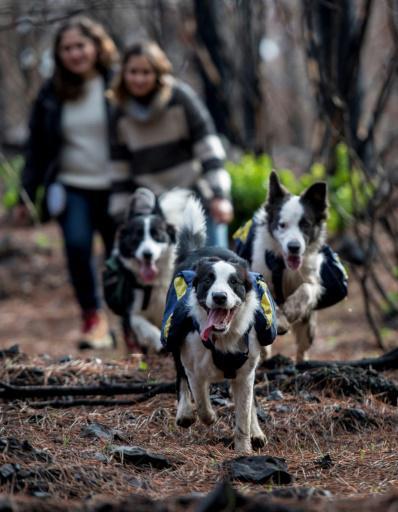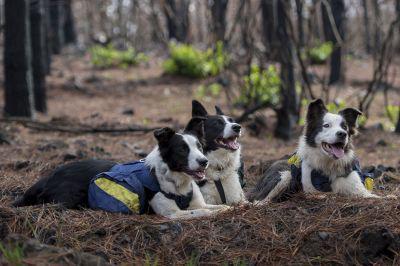The first image is the image on the left, the second image is the image on the right. Examine the images to the left and right. Is the description "The left image contains two dogs that are not wearing vests, and the right image features a girl in a striped sweater with at least one dog wearing a vest pack." accurate? Answer yes or no. No. The first image is the image on the left, the second image is the image on the right. For the images displayed, is the sentence "One or more of the images has three dogs." factually correct? Answer yes or no. Yes. 